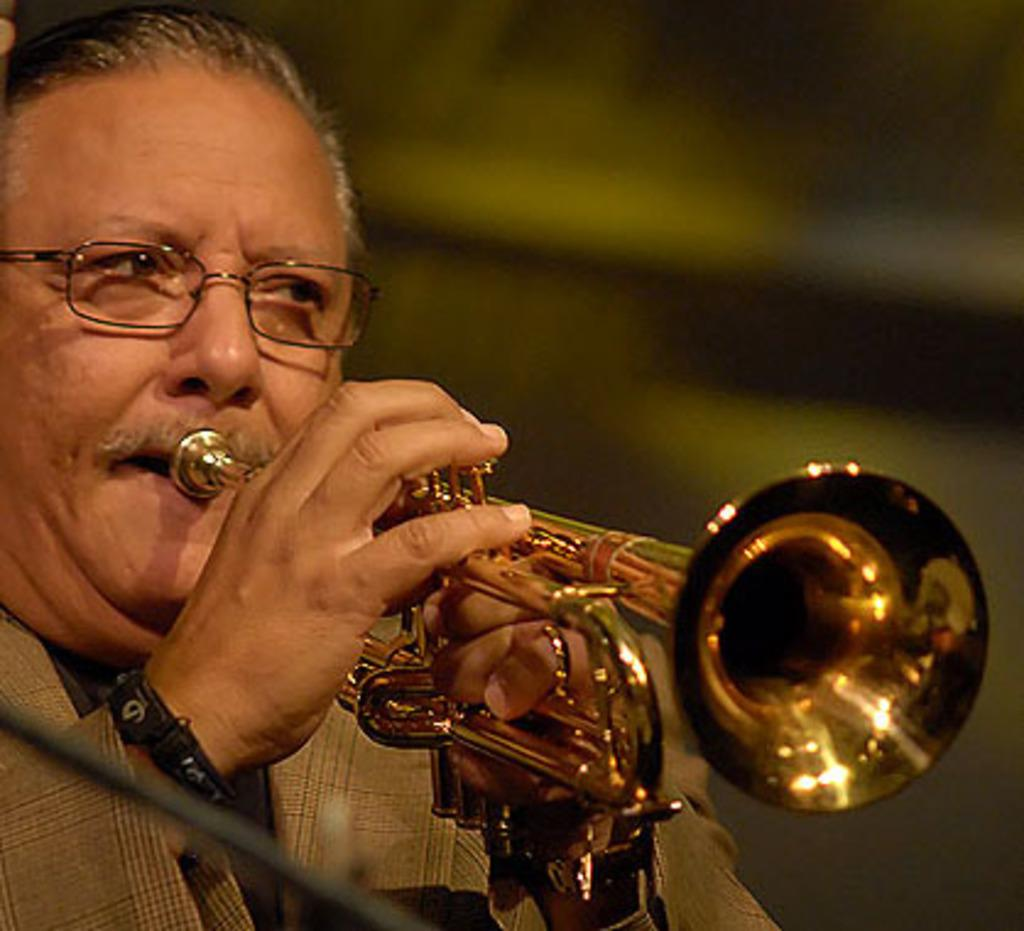What is the main subject of the image? There is a person in the image. What is the person wearing? The person is wearing clothes. What activity is the person engaged in? The person is playing a musical instrument. Can you describe the background of the image? The background of the image is blurred. What type of hydrant can be seen in the background of the image? There is no hydrant present in the image; the background is blurred. Can you describe the hen that is sitting on the person's lap while they play the musical instrument? There is no hen present in the image; the person is playing a musical instrument without any animals. 